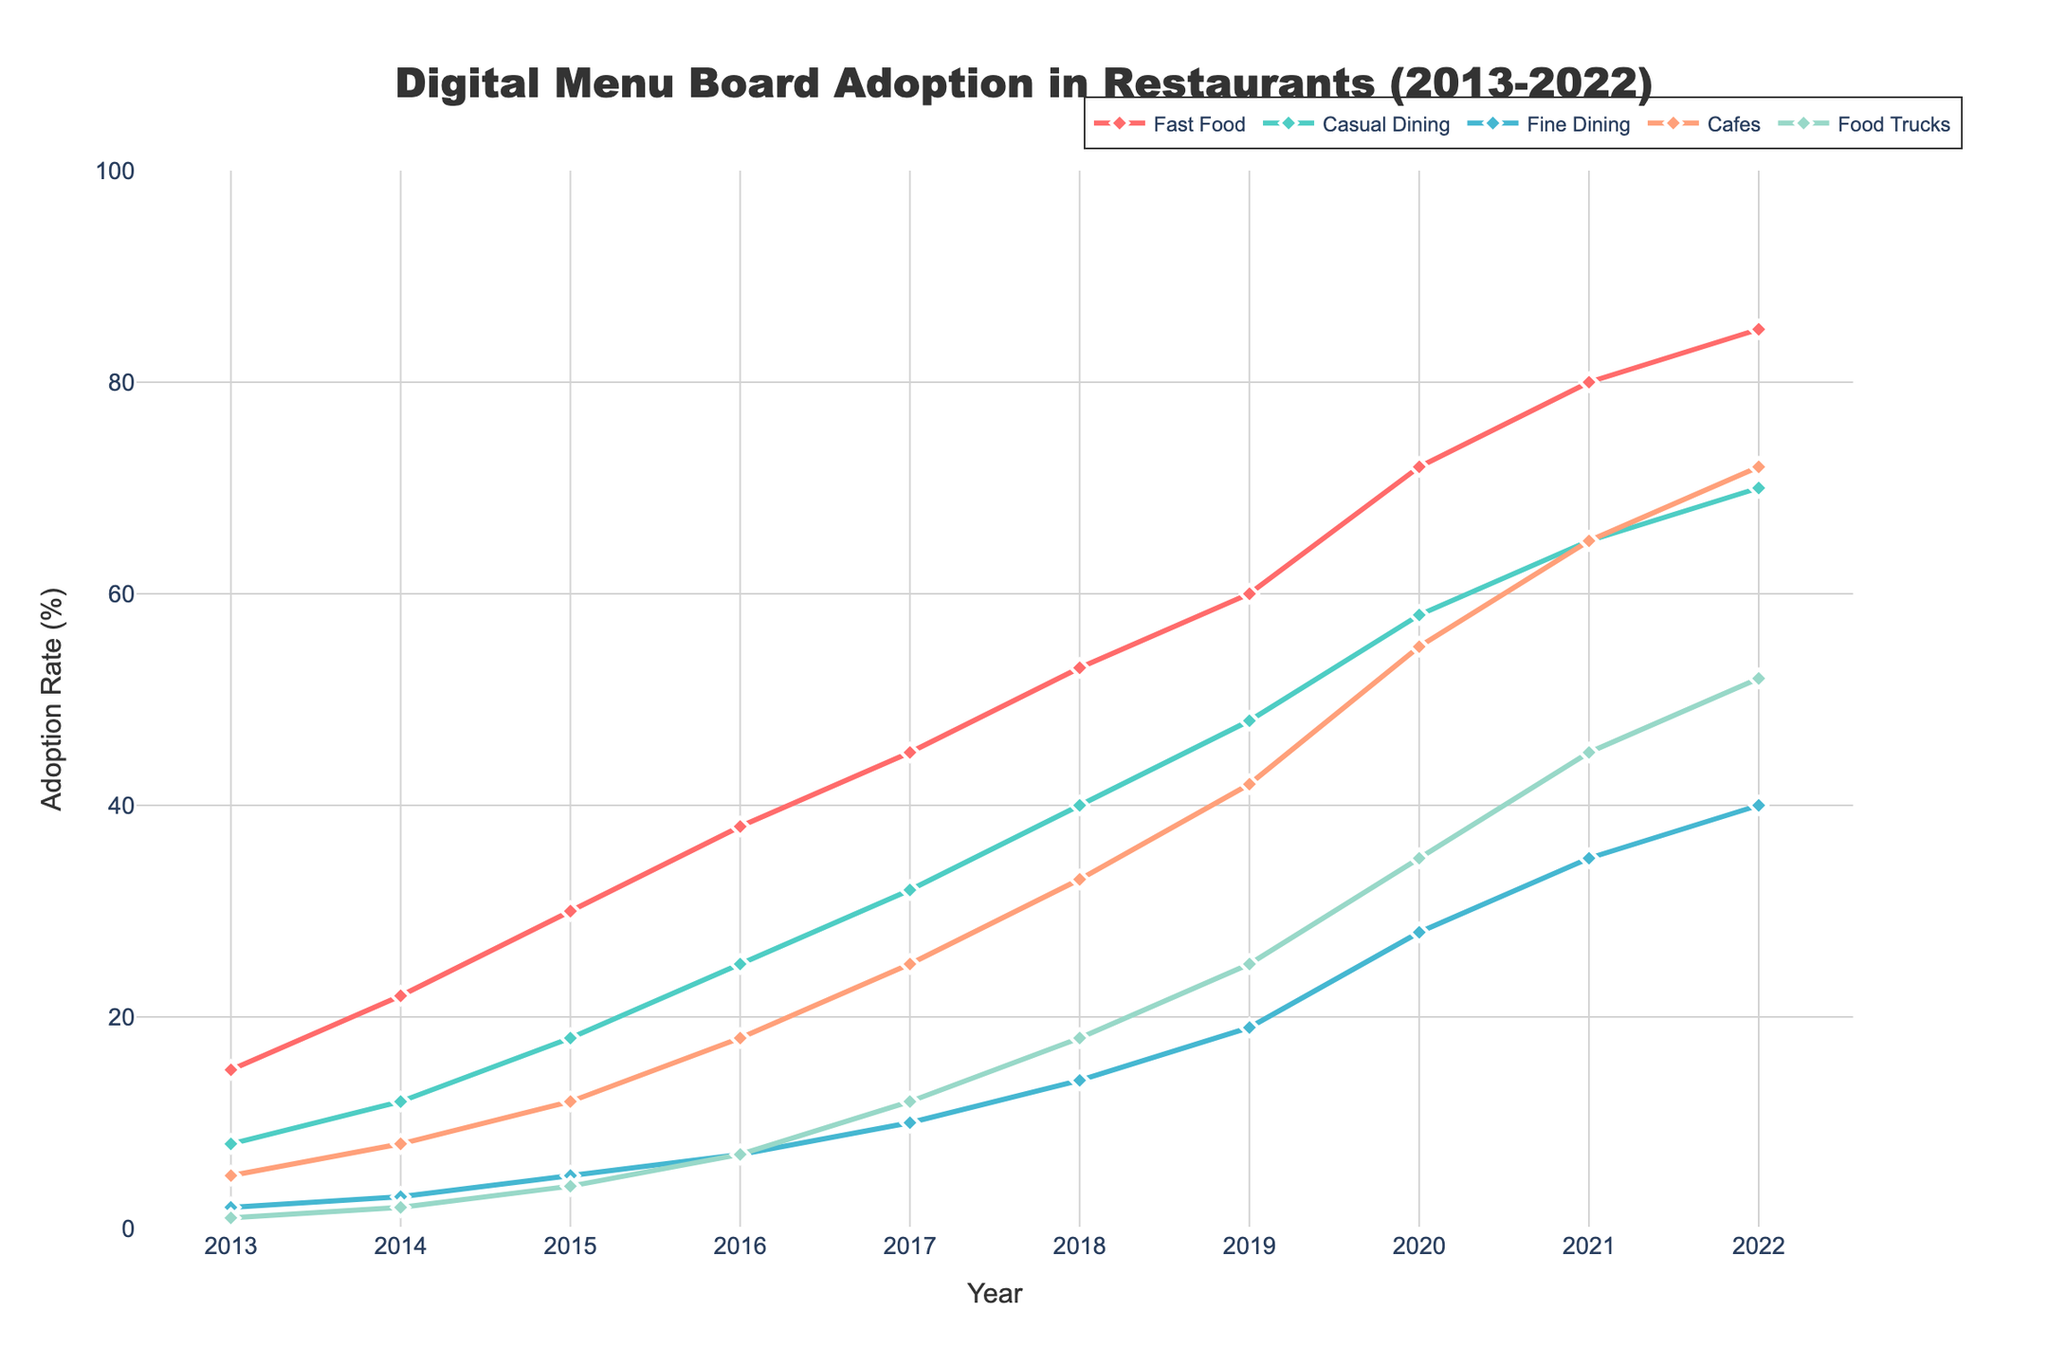What year did Fast Food restaurants surpass a 50% adoption rate of digital menu boards? The line representing Fast Food adoption rate crosses the 50% mark in the year 2018.
Answer: 2018 Which restaurant type had the highest adoption rate in 2020? The line chart shows different colors representing different restaurant types. By looking at the 2020 markers, Fast Food restaurants showed the highest adoption rate.
Answer: Fast Food By how much did the adoption rate of digital menu boards in Food Trucks increase from 2015 to 2018? In 2015, the adoption rate for Food Trucks was 4%, and in 2018, it was 18%. The increase is 18% - 4% = 14%.
Answer: 14% Compare the adoption rates of Cafes and Fine Dining in 2021. Which one was higher and by how much? In 2021, the adoption rate for Cafes was 65%, and for Fine Dining, it was 35%. Cafes had a higher adoption rate by 65% - 35% = 30%.
Answer: Cafes by 30% What is the average adoption rate of Fine Dining in the years 2017, 2018, and 2019? The adoption rates for Fine Dining in 2017, 2018, and 2019 are 10%, 14%, and 19% respectively. The average is (10 + 14 + 19) / 3 = 14.33%.
Answer: 14.33% In which year did Casual Dining restaurants reach a 58% adoption rate? Referring to the chart, the line for Casual Dining reaches 58% in the year 2020.
Answer: 2020 What is the trend of adoption for Cafes from 2019 to 2022? Observing the markers for Cafes from 2019 to 2022, the adoption rate increased from 42% in 2019 to 72% in 2022, indicating a steady upward trend.
Answer: Steady upward trend Find the difference in the adoption rates of Fast Food and Casual Dining in 2018. In 2018, the adoption rate for Fast Food was 53% and for Casual Dining, it was 40%. The difference is 53% - 40% = 13%.
Answer: 13% Which restaurant type showed the most significant increase in adoption from 2015 to 2020? Comparing the difference from 2015 to 2020 for all types, Fast Food increased from 30% to 72%, a 42% increase, the highest among all types.
Answer: Fast Food Which restaurant type had the lowest adoption rate in 2016 and what was that rate? Checking the chart, Food Trucks had the lowest adoption rate in 2016 at 7%.
Answer: Food Trucks, 7% 